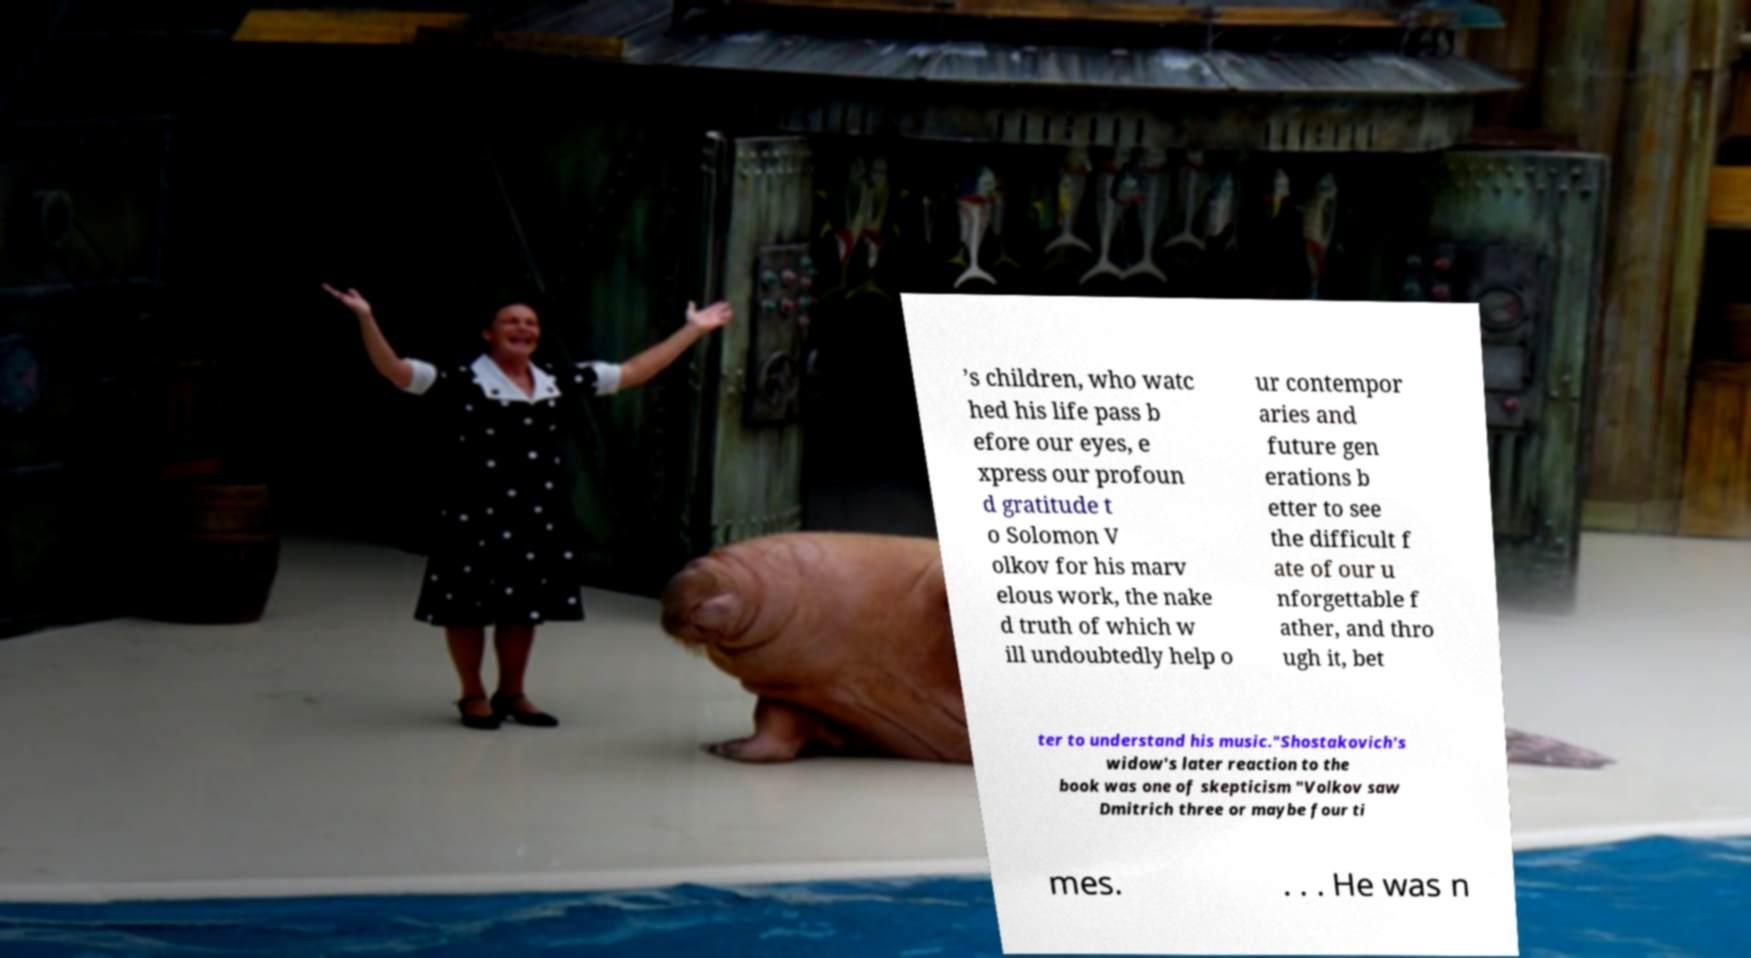I need the written content from this picture converted into text. Can you do that? ’s children, who watc hed his life pass b efore our eyes, e xpress our profoun d gratitude t o Solomon V olkov for his marv elous work, the nake d truth of which w ill undoubtedly help o ur contempor aries and future gen erations b etter to see the difficult f ate of our u nforgettable f ather, and thro ugh it, bet ter to understand his music."Shostakovich's widow's later reaction to the book was one of skepticism "Volkov saw Dmitrich three or maybe four ti mes. . . . He was n 